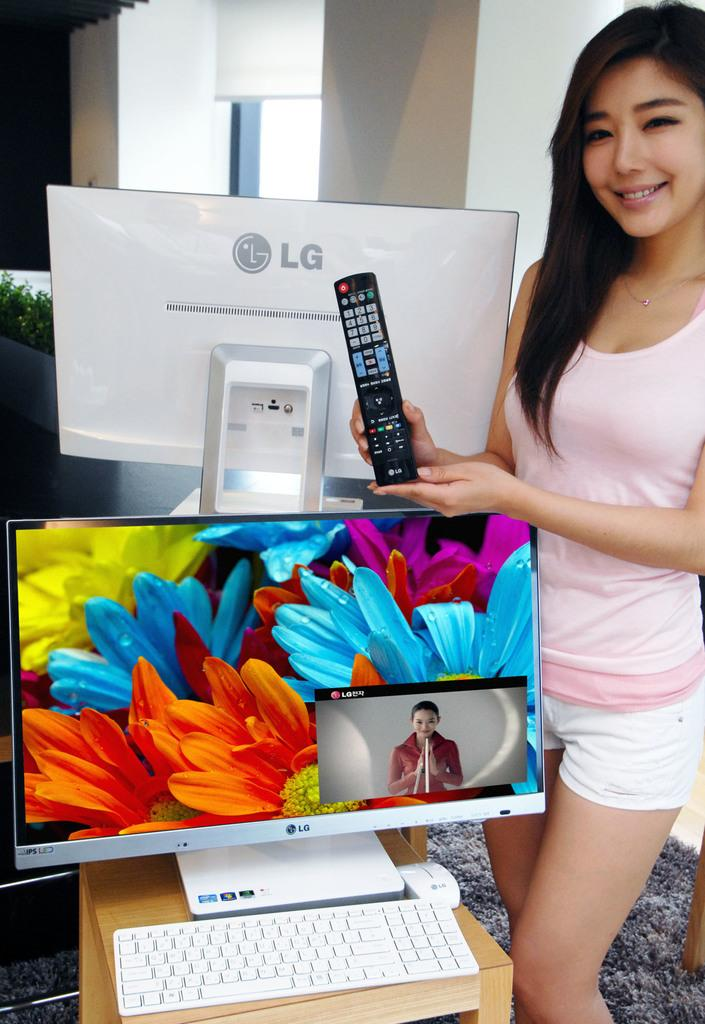<image>
Render a clear and concise summary of the photo. A woman holds up a remote over and in front of LG monitors. 